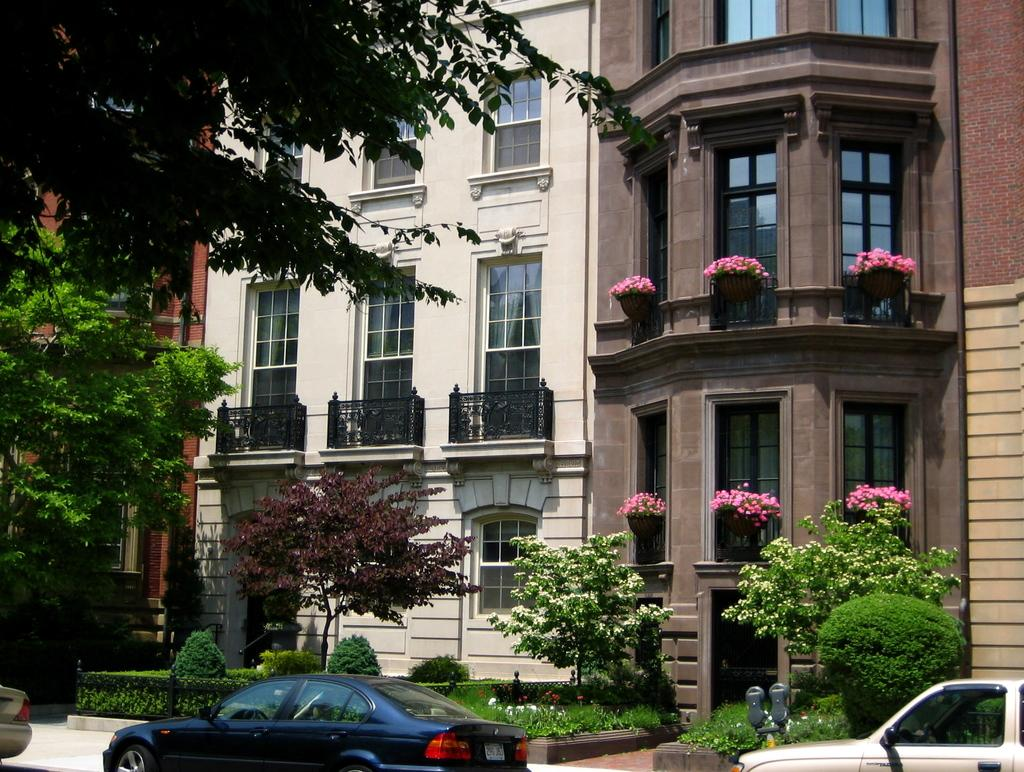What can be seen in the front of the image? There are vehicles in the front of the image. What is visible in the background of the image? There are trees, plants, flowers, and buildings in the background of the image. What type of vegetation is present on the ground in the image? There is grass on the ground in the image. Where is the goat sitting on its throne in the image? There is no goat or throne present in the image. What color is the ball in the image? There is no ball present in the image. 